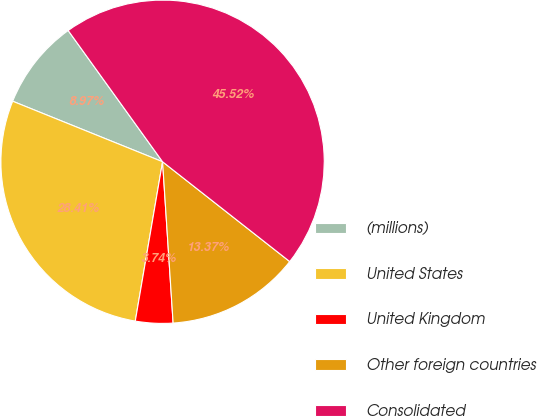Convert chart. <chart><loc_0><loc_0><loc_500><loc_500><pie_chart><fcel>(millions)<fcel>United States<fcel>United Kingdom<fcel>Other foreign countries<fcel>Consolidated<nl><fcel>8.97%<fcel>28.41%<fcel>3.74%<fcel>13.37%<fcel>45.52%<nl></chart> 